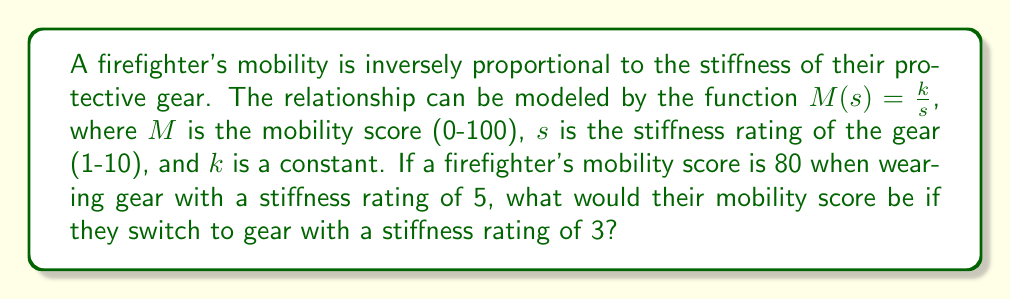Can you solve this math problem? Let's approach this step-by-step:

1) We're given that $M(s) = \frac{k}{s}$, where $k$ is a constant we need to determine.

2) We know that when $s = 5$, $M = 80$. Let's use this to find $k$:

   $80 = \frac{k}{5}$

3) Multiply both sides by 5:

   $400 = k$

4) Now that we know $k = 400$, we can write our specific function:

   $M(s) = \frac{400}{s}$

5) To find the mobility score with gear of stiffness rating 3, we simply plug in $s = 3$:

   $M(3) = \frac{400}{3}$

6) Simplify:

   $M(3) = \frac{400}{3} = 133.33...$

7) Since mobility scores are on a scale of 0-100, we need to cap this at 100.

Therefore, the firefighter's mobility score with gear of stiffness rating 3 would be 100.
Answer: 100 